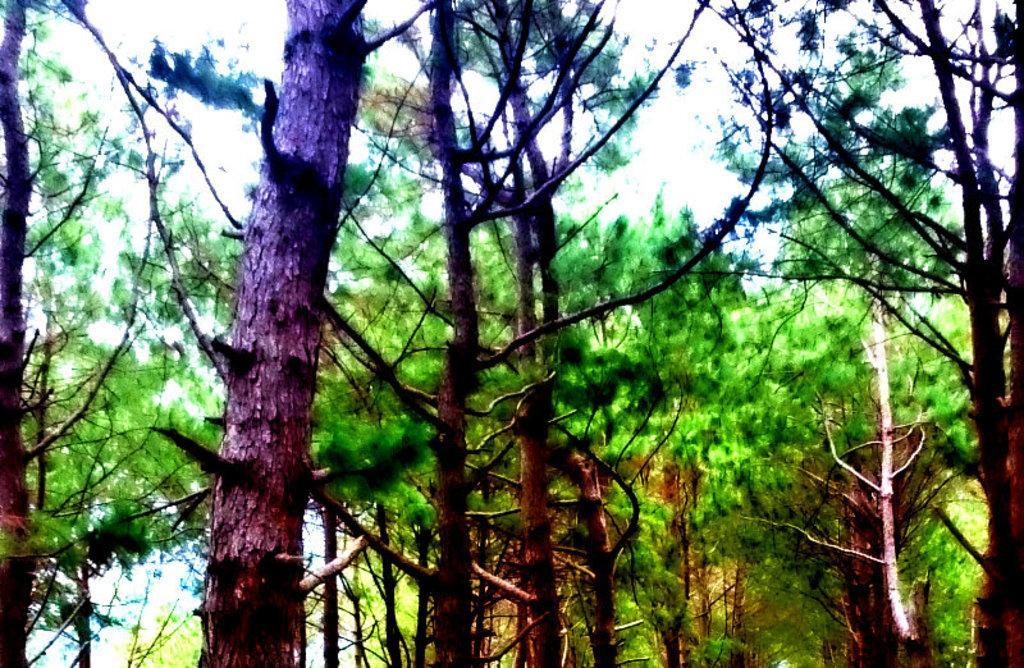Describe this image in one or two sentences. In this image we can see a group of trees. At the top of the image we can see the sky. 